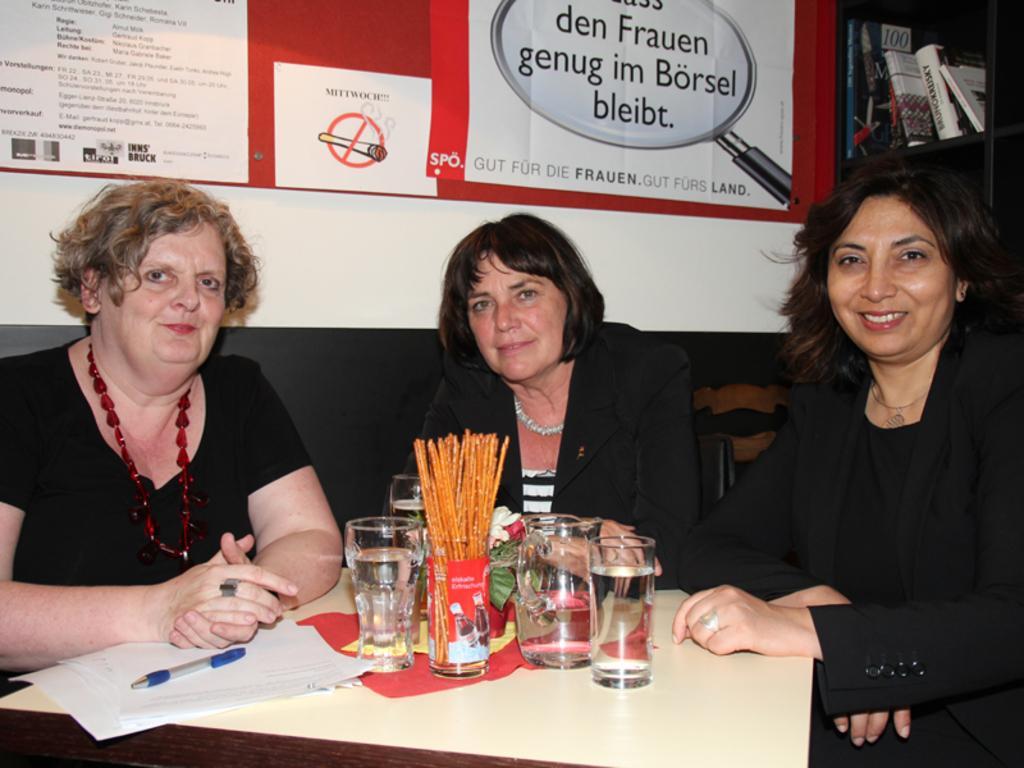In one or two sentences, can you explain what this image depicts? These 3 women are sitting on a chair. On this table there is a container, glasses, paper and pen. A banner on wall. This rack is filled with books. 